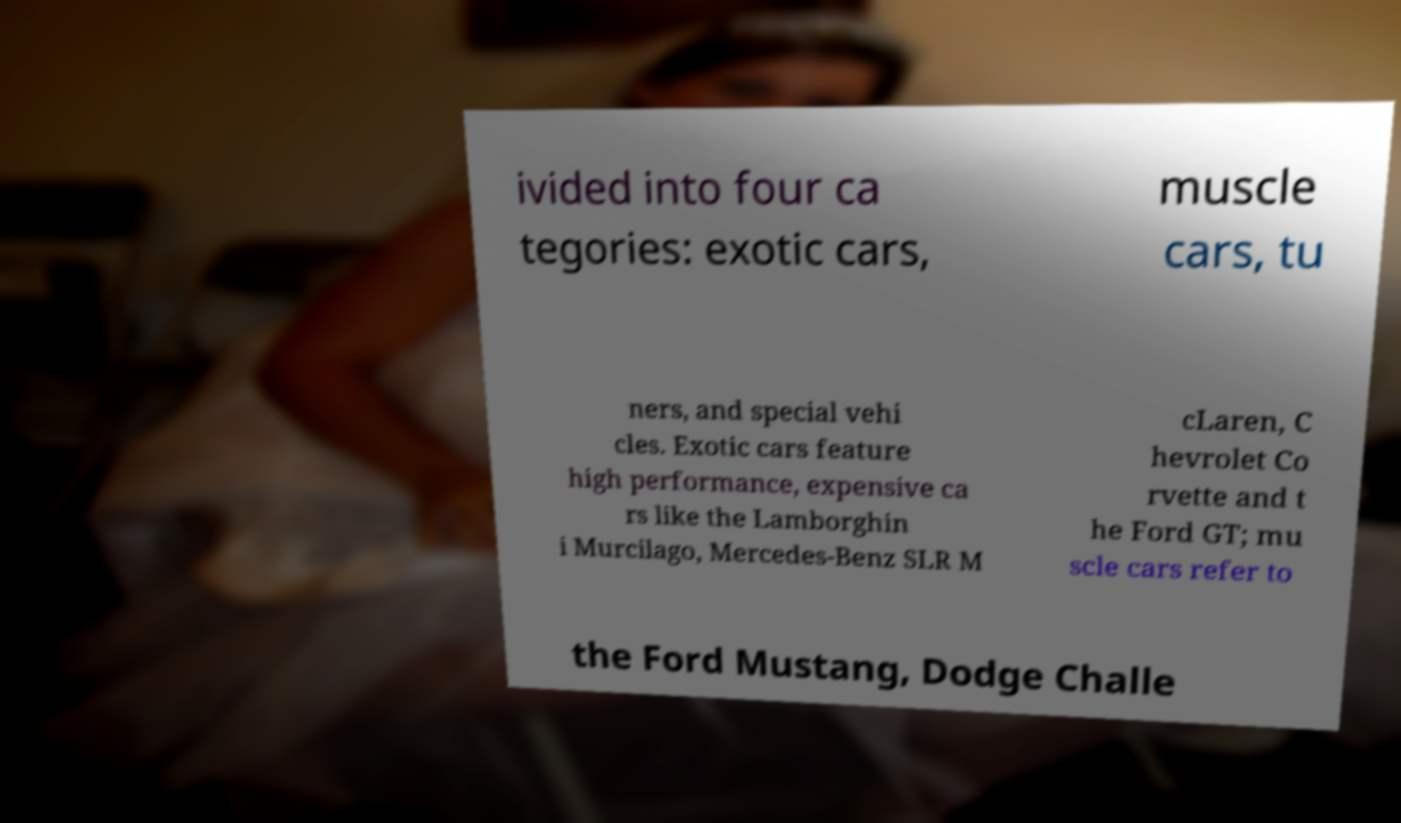Please identify and transcribe the text found in this image. ivided into four ca tegories: exotic cars, muscle cars, tu ners, and special vehi cles. Exotic cars feature high performance, expensive ca rs like the Lamborghin i Murcilago, Mercedes-Benz SLR M cLaren, C hevrolet Co rvette and t he Ford GT; mu scle cars refer to the Ford Mustang, Dodge Challe 